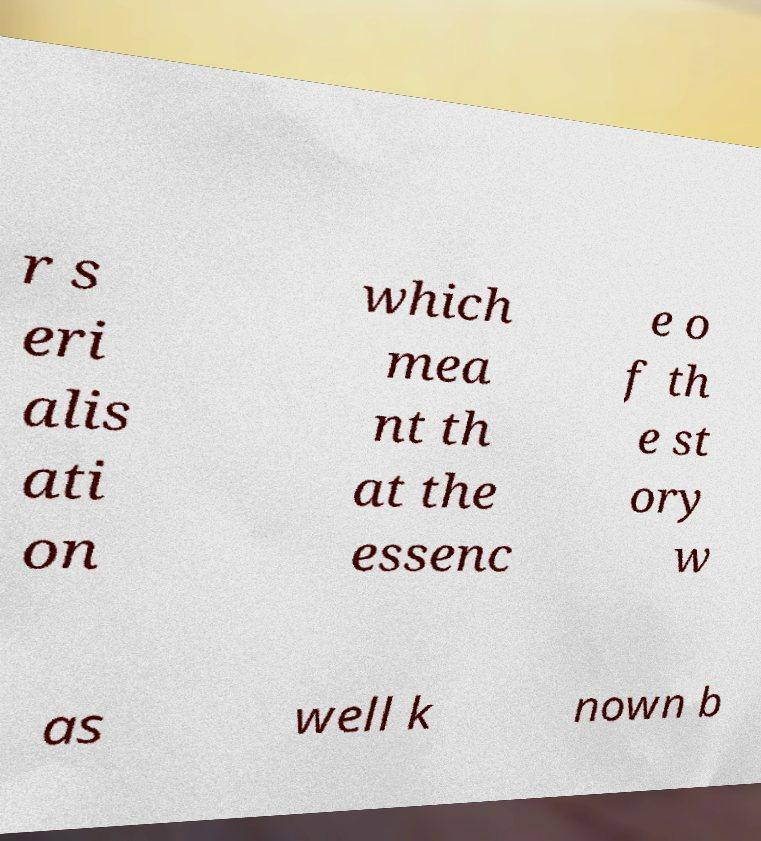Could you assist in decoding the text presented in this image and type it out clearly? r s eri alis ati on which mea nt th at the essenc e o f th e st ory w as well k nown b 